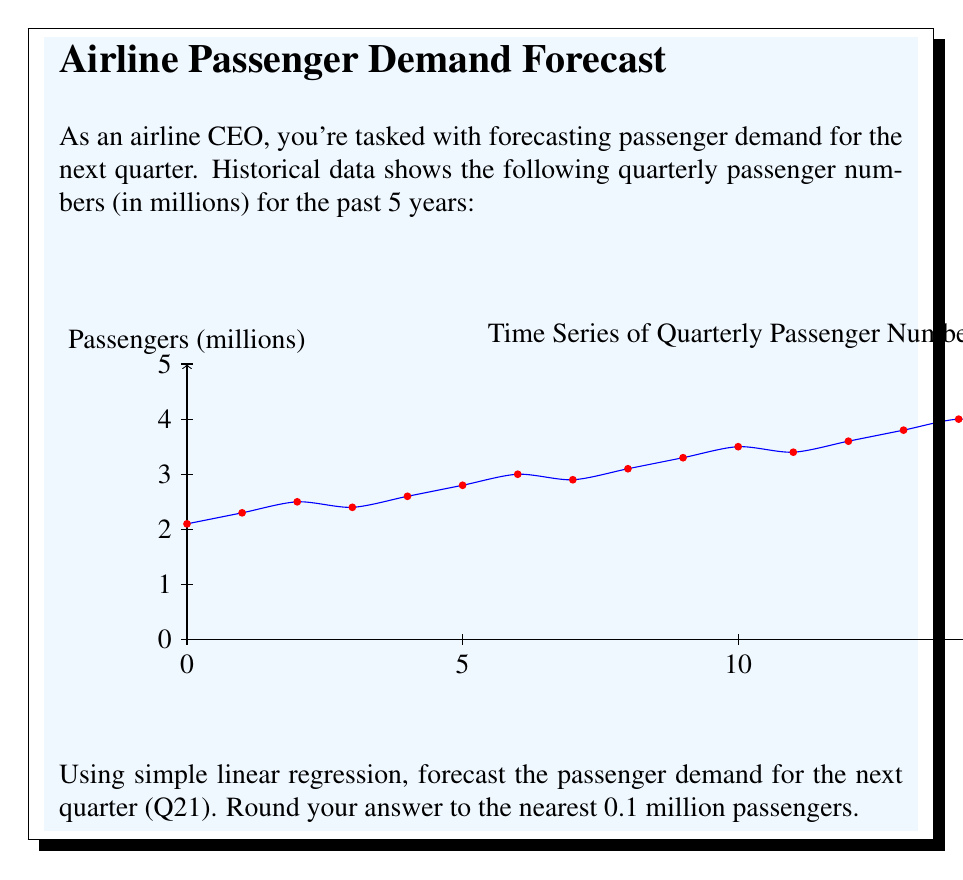Can you solve this math problem? To forecast passenger demand using simple linear regression:

1) Let $x$ represent the quarter number and $y$ represent the passenger count in millions.

2) Calculate the means:
   $\bar{x} = \frac{1+2+...+20}{20} = 10.5$
   $\bar{y} = \frac{2.1+2.3+...+4.4}{20} = 3.275$

3) Calculate $\sum_{i=1}^{20} (x_i - \bar{x})(y_i - \bar{y})$ and $\sum_{i=1}^{20} (x_i - \bar{x})^2$:
   $\sum_{i=1}^{20} (x_i - \bar{x})(y_i - \bar{y}) = 76.65$
   $\sum_{i=1}^{20} (x_i - \bar{x})^2 = 665$

4) Calculate the slope $b$:
   $b = \frac{\sum_{i=1}^{20} (x_i - \bar{x})(y_i - \bar{y})}{\sum_{i=1}^{20} (x_i - \bar{x})^2} = \frac{76.65}{665} = 0.1153$

5) Calculate the y-intercept $a$:
   $a = \bar{y} - b\bar{x} = 3.275 - 0.1153 * 10.5 = 2.0644$

6) The regression line equation is:
   $y = 0.1153x + 2.0644$

7) To forecast Q21, substitute $x = 21$:
   $y = 0.1153 * 21 + 2.0644 = 4.4857$

8) Rounding to the nearest 0.1 million:
   $4.4857 \approx 4.5$ million passengers
Answer: 4.5 million passengers 